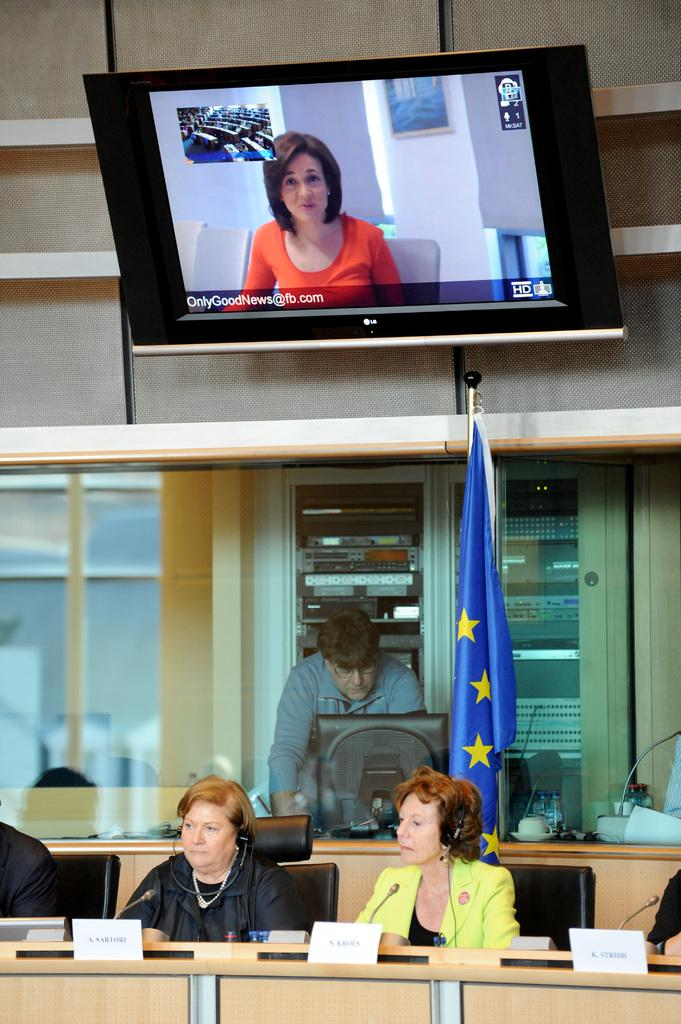What is shown in the top image? The top image displays a news channel. What is happening in the bottom image? The bottom image displays a group of people sitting in a chair. Can you describe the background of the bottom image? There is a person standing in the background of the bottom image. What color paint is being used by the person in the top image? There is no person or paint present in the top image, as it displays a news channel. 